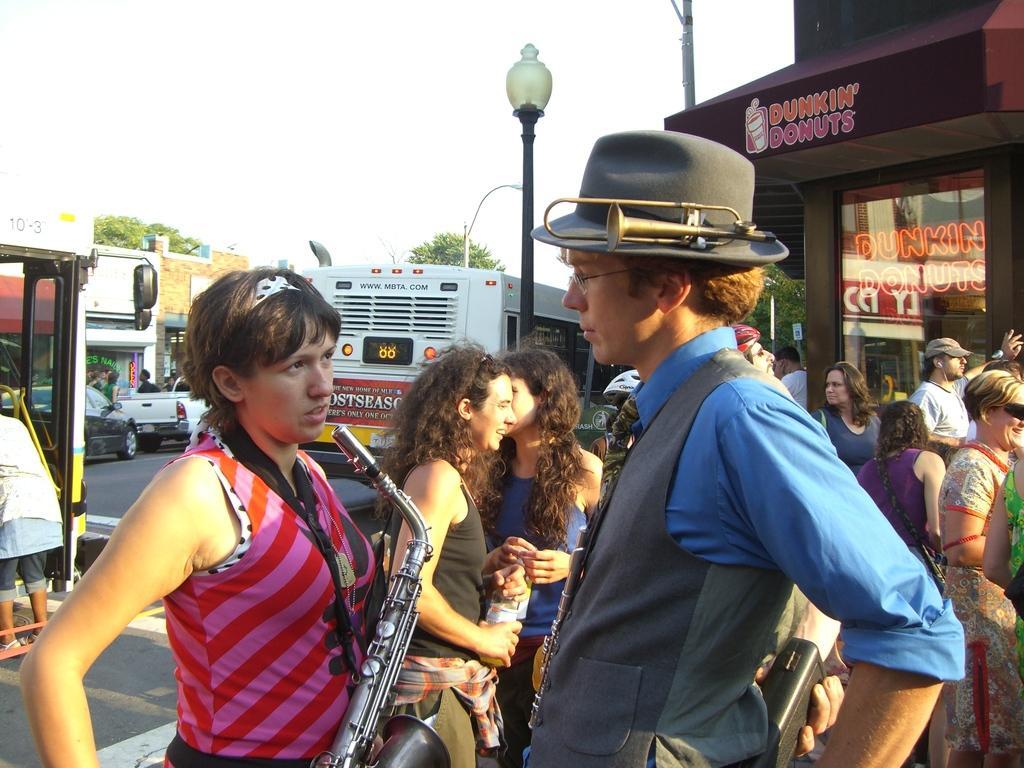Describe this image in one or two sentences. In this image we can see persons standing on the road and one of them is holding musical instruments in the hands. In the background we can see motor vehicles, street pole, street lights, sky, trees and a store. 